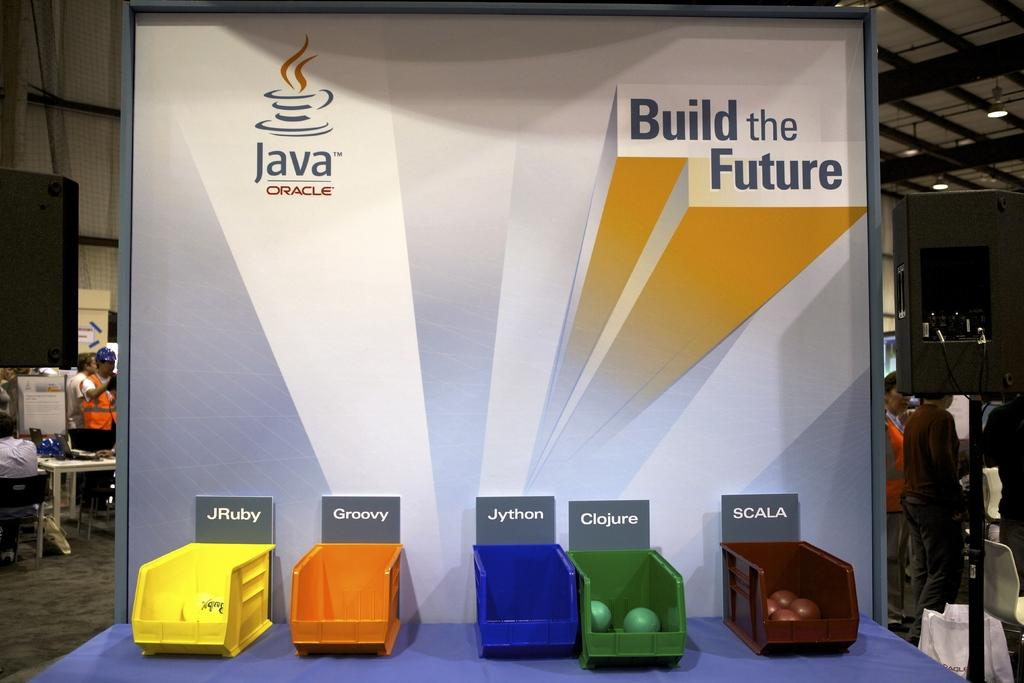<image>
Relay a brief, clear account of the picture shown. a display at an event for Java reading Build the Future 